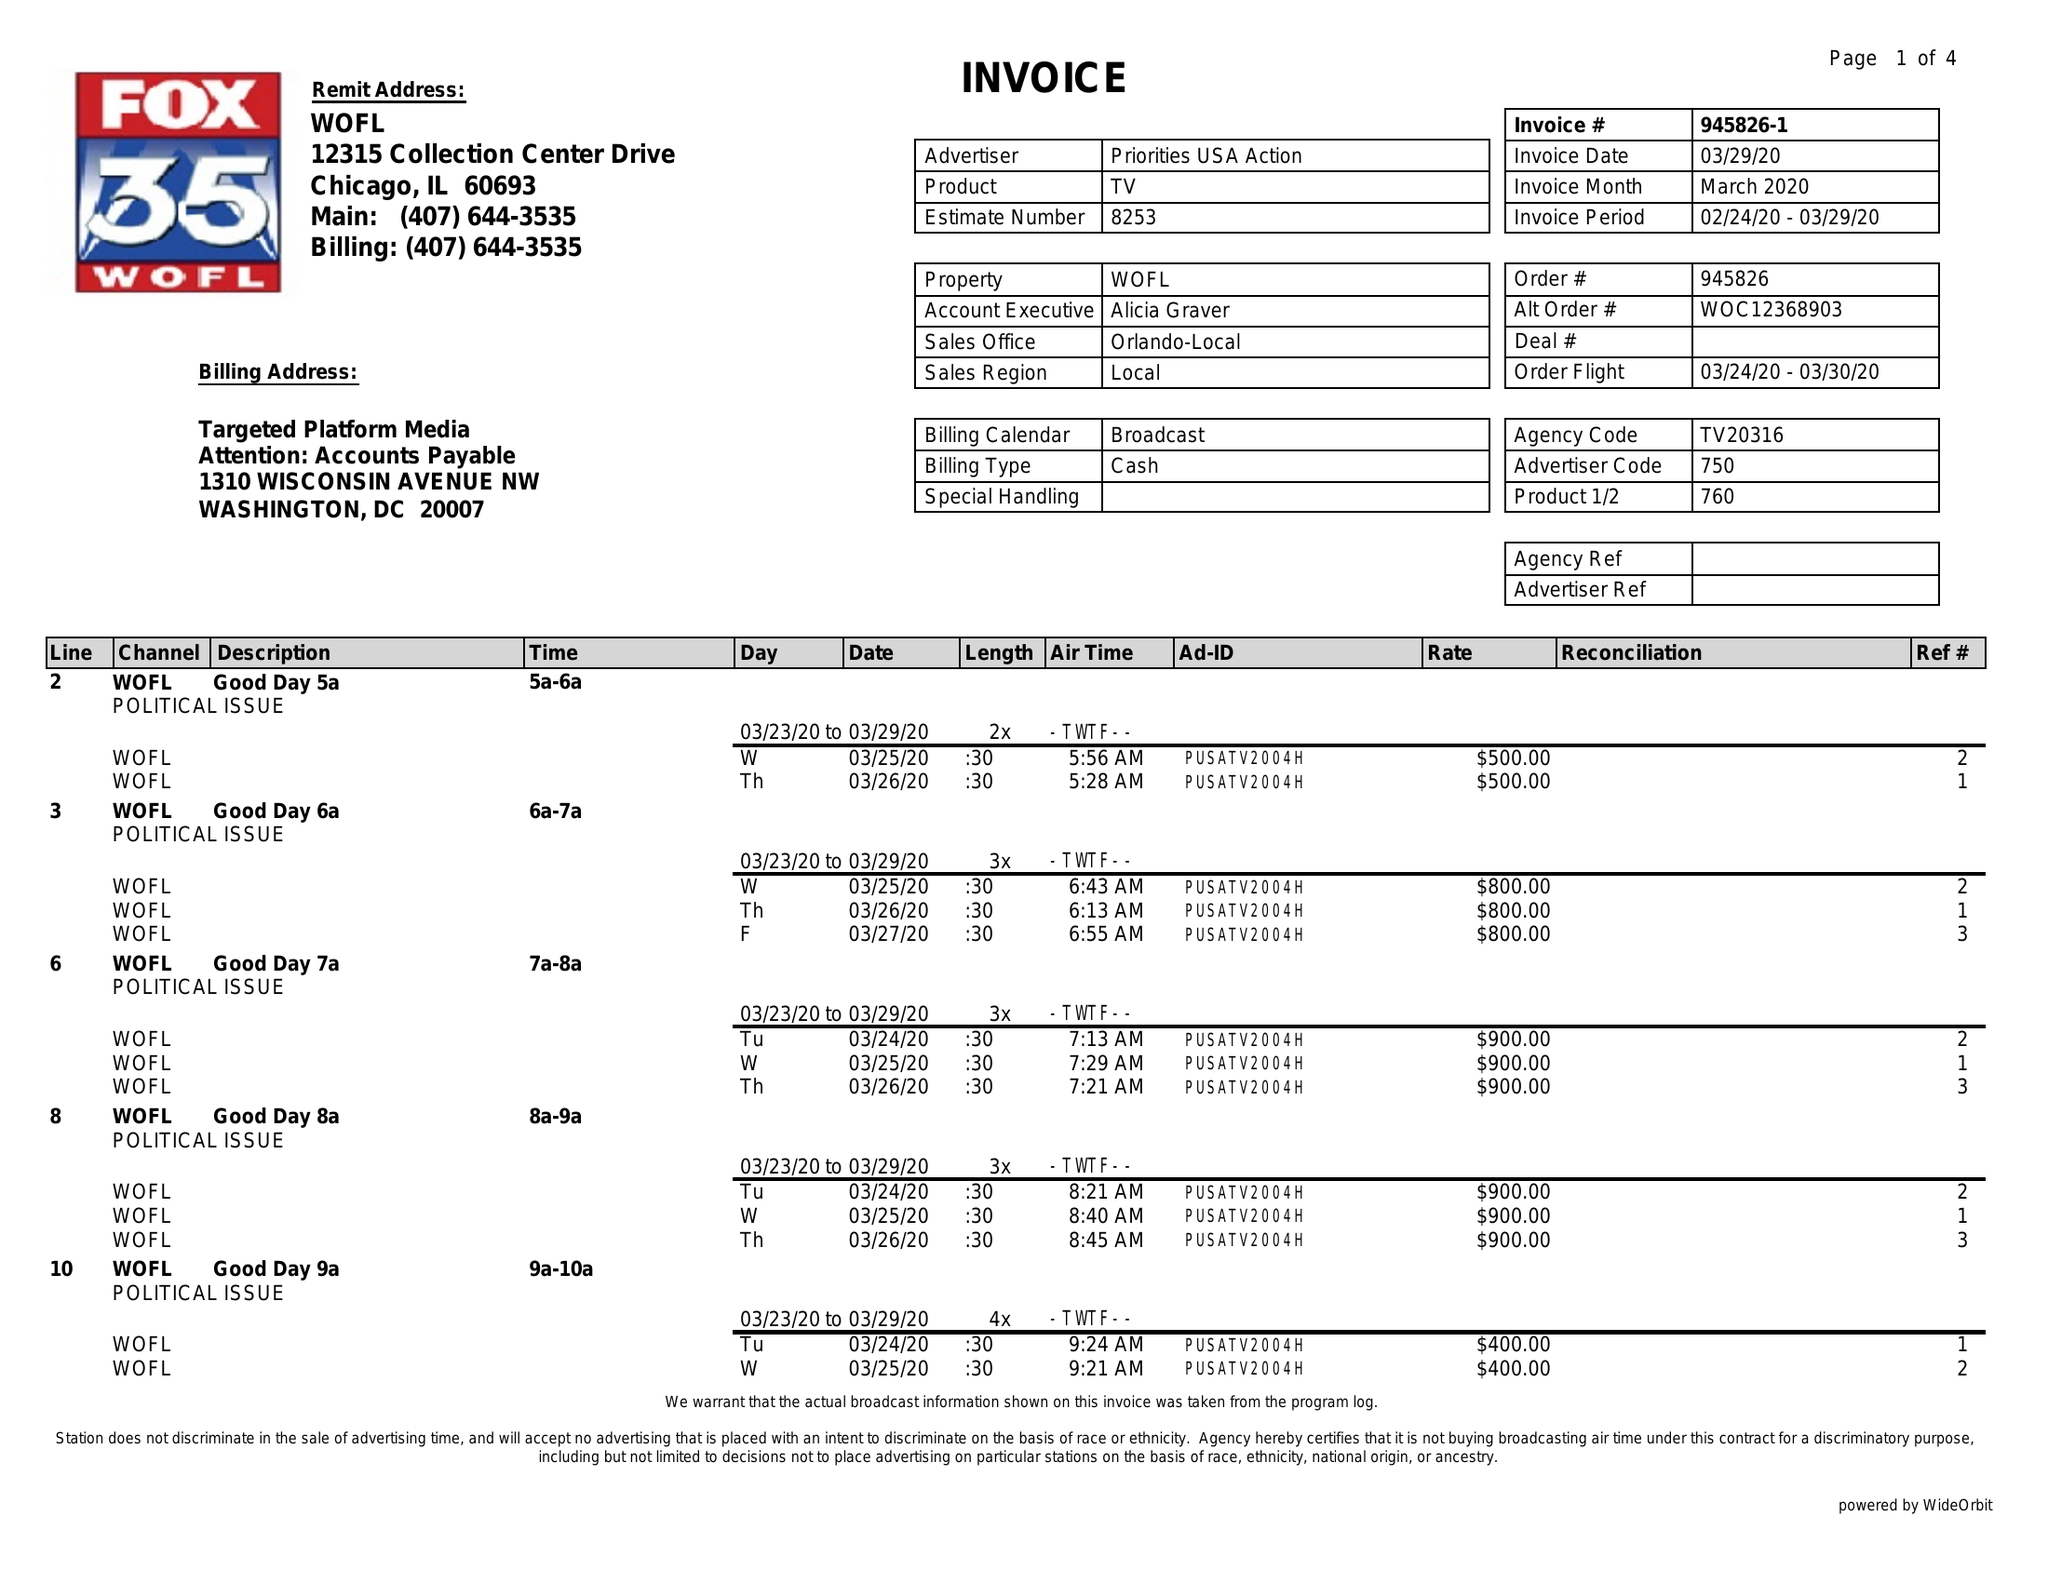What is the value for the gross_amount?
Answer the question using a single word or phrase. 27100.00 